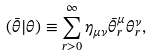Convert formula to latex. <formula><loc_0><loc_0><loc_500><loc_500>( { \bar { \theta } } | \theta ) \equiv \sum _ { r > 0 } ^ { \infty } \eta _ { \mu \nu } { \bar { \theta } } ^ { \mu } _ { r } \theta ^ { \nu } _ { r } ,</formula> 